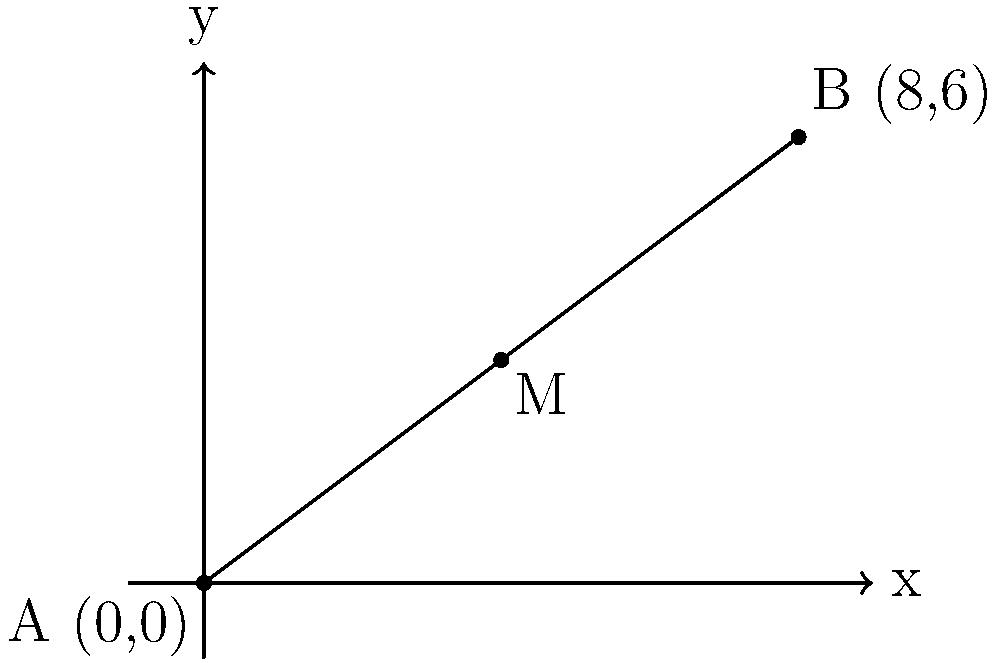Dr. Smith's daily commute from home to the hospital is represented by a line segment on a coordinate plane. The starting point of his journey (his home) is at (0,0), and the endpoint (the hospital) is at (8,6). As his lawyer, you've noticed his exhaustion from the long commute. To suggest a potential rest stop, you need to determine the coordinates of the midpoint of his commute route. What are the coordinates of this midpoint? To find the midpoint of a line segment, we can use the midpoint formula:

$$ M_x = \frac{x_1 + x_2}{2}, M_y = \frac{y_1 + y_2}{2} $$

Where $(x_1, y_1)$ is the starting point and $(x_2, y_2)$ is the endpoint.

Step 1: Identify the coordinates
- Starting point (home): $(x_1, y_1) = (0, 0)$
- Endpoint (hospital): $(x_2, y_2) = (8, 6)$

Step 2: Calculate the x-coordinate of the midpoint
$$ M_x = \frac{x_1 + x_2}{2} = \frac{0 + 8}{2} = \frac{8}{2} = 4 $$

Step 3: Calculate the y-coordinate of the midpoint
$$ M_y = \frac{y_1 + y_2}{2} = \frac{0 + 6}{2} = \frac{6}{2} = 3 $$

Step 4: Combine the results
The midpoint coordinates are $(M_x, M_y) = (4, 3)$
Answer: $(4, 3)$ 